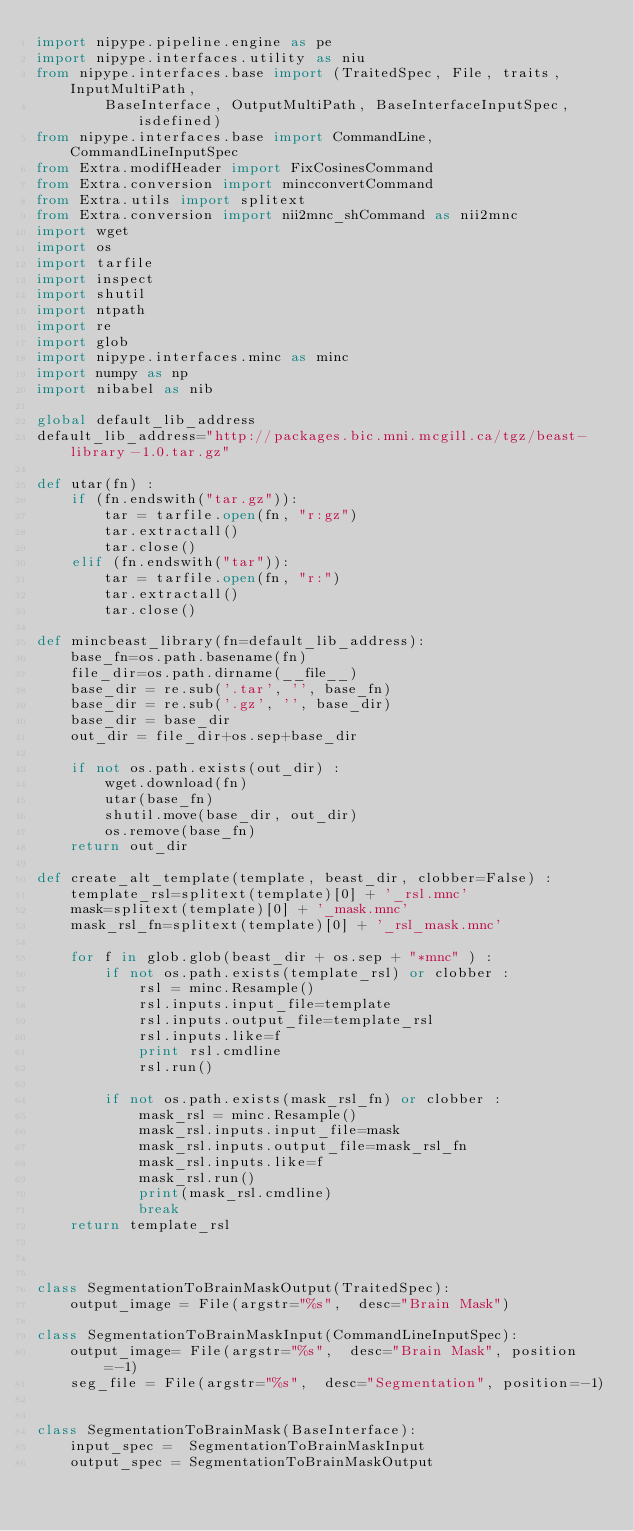Convert code to text. <code><loc_0><loc_0><loc_500><loc_500><_Python_>import nipype.pipeline.engine as pe
import nipype.interfaces.utility as niu
from nipype.interfaces.base import (TraitedSpec, File, traits, InputMultiPath,
		BaseInterface, OutputMultiPath, BaseInterfaceInputSpec, isdefined)
from nipype.interfaces.base import CommandLine, CommandLineInputSpec
from Extra.modifHeader import FixCosinesCommand
from Extra.conversion import mincconvertCommand
from Extra.utils import splitext
from Extra.conversion import nii2mnc_shCommand as nii2mnc
import wget
import os
import tarfile
import inspect
import shutil
import ntpath
import re
import glob
import nipype.interfaces.minc as minc
import numpy as np
import nibabel as nib

global default_lib_address
default_lib_address="http://packages.bic.mni.mcgill.ca/tgz/beast-library-1.0.tar.gz"

def utar(fn) :
	if (fn.endswith("tar.gz")):
		tar = tarfile.open(fn, "r:gz")
		tar.extractall()
		tar.close()
	elif (fn.endswith("tar")):
		tar = tarfile.open(fn, "r:")
		tar.extractall()
		tar.close()

def mincbeast_library(fn=default_lib_address):
	base_fn=os.path.basename(fn)
	file_dir=os.path.dirname(__file__)
	base_dir = re.sub('.tar', '', base_fn)
	base_dir = re.sub('.gz', '', base_dir)
	base_dir = base_dir
	out_dir = file_dir+os.sep+base_dir

	if not os.path.exists(out_dir) :
		wget.download(fn)
		utar(base_fn)
		shutil.move(base_dir, out_dir)
		os.remove(base_fn)
	return out_dir

def create_alt_template(template, beast_dir, clobber=False) :
    template_rsl=splitext(template)[0] + '_rsl.mnc'
    mask=splitext(template)[0] + '_mask.mnc'
    mask_rsl_fn=splitext(template)[0] + '_rsl_mask.mnc'

    for f in glob.glob(beast_dir + os.sep + "*mnc" ) :
        if not os.path.exists(template_rsl) or clobber :
            rsl = minc.Resample()
            rsl.inputs.input_file=template
            rsl.inputs.output_file=template_rsl
            rsl.inputs.like=f
            print rsl.cmdline
            rsl.run()

        if not os.path.exists(mask_rsl_fn) or clobber :
            mask_rsl = minc.Resample()
            mask_rsl.inputs.input_file=mask
            mask_rsl.inputs.output_file=mask_rsl_fn
            mask_rsl.inputs.like=f
            mask_rsl.run()
            print(mask_rsl.cmdline)
            break
    return template_rsl



class SegmentationToBrainMaskOutput(TraitedSpec):
	output_image = File(argstr="%s",  desc="Brain Mask")

class SegmentationToBrainMaskInput(CommandLineInputSpec):
	output_image= File(argstr="%s",  desc="Brain Mask", position=-1)
	seg_file = File(argstr="%s",  desc="Segmentation", position=-1)


class SegmentationToBrainMask(BaseInterface):
	input_spec =  SegmentationToBrainMaskInput
	output_spec = SegmentationToBrainMaskOutput

</code> 